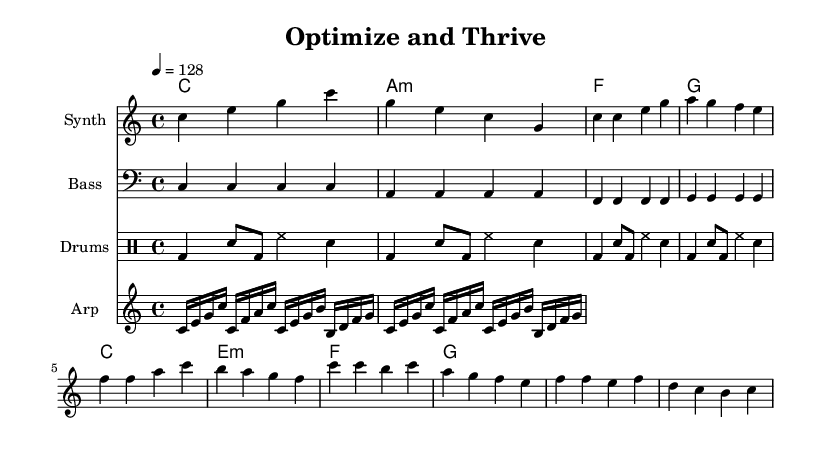What is the key signature of this music? The key signature is C major, which has no sharps or flats.
Answer: C major What is the time signature of this music? The time signature indicated at the beginning of the score is 4/4, meaning there are four beats in each measure.
Answer: 4/4 What is the tempo marking for this piece? The tempo marking is indicated as a quarter note = 128 beats per minute.
Answer: 128 How many measures are in the melody section before the chorus starts? Counting through the melody, there are six measures before transitioning to the chorus section.
Answer: 6 Which chord follows the A minor chord in the harmony progression? Observing the chord progression, after A minor, the next chord is F major.
Answer: F How many repeats are indicated for the drum pattern? The drum pattern uses "repeat unfold 4" which indicates the pattern is repeated four times.
Answer: 4 What type of instrument is used for the arpeggiator in the score? The arpeggiator is notated on a staff labeled specifically for "Arp," indicating it is likely synthesizer-based.
Answer: Synth 